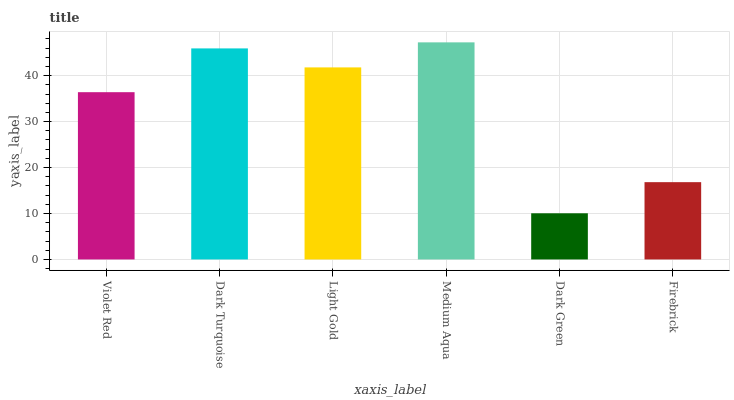Is Dark Green the minimum?
Answer yes or no. Yes. Is Medium Aqua the maximum?
Answer yes or no. Yes. Is Dark Turquoise the minimum?
Answer yes or no. No. Is Dark Turquoise the maximum?
Answer yes or no. No. Is Dark Turquoise greater than Violet Red?
Answer yes or no. Yes. Is Violet Red less than Dark Turquoise?
Answer yes or no. Yes. Is Violet Red greater than Dark Turquoise?
Answer yes or no. No. Is Dark Turquoise less than Violet Red?
Answer yes or no. No. Is Light Gold the high median?
Answer yes or no. Yes. Is Violet Red the low median?
Answer yes or no. Yes. Is Medium Aqua the high median?
Answer yes or no. No. Is Firebrick the low median?
Answer yes or no. No. 